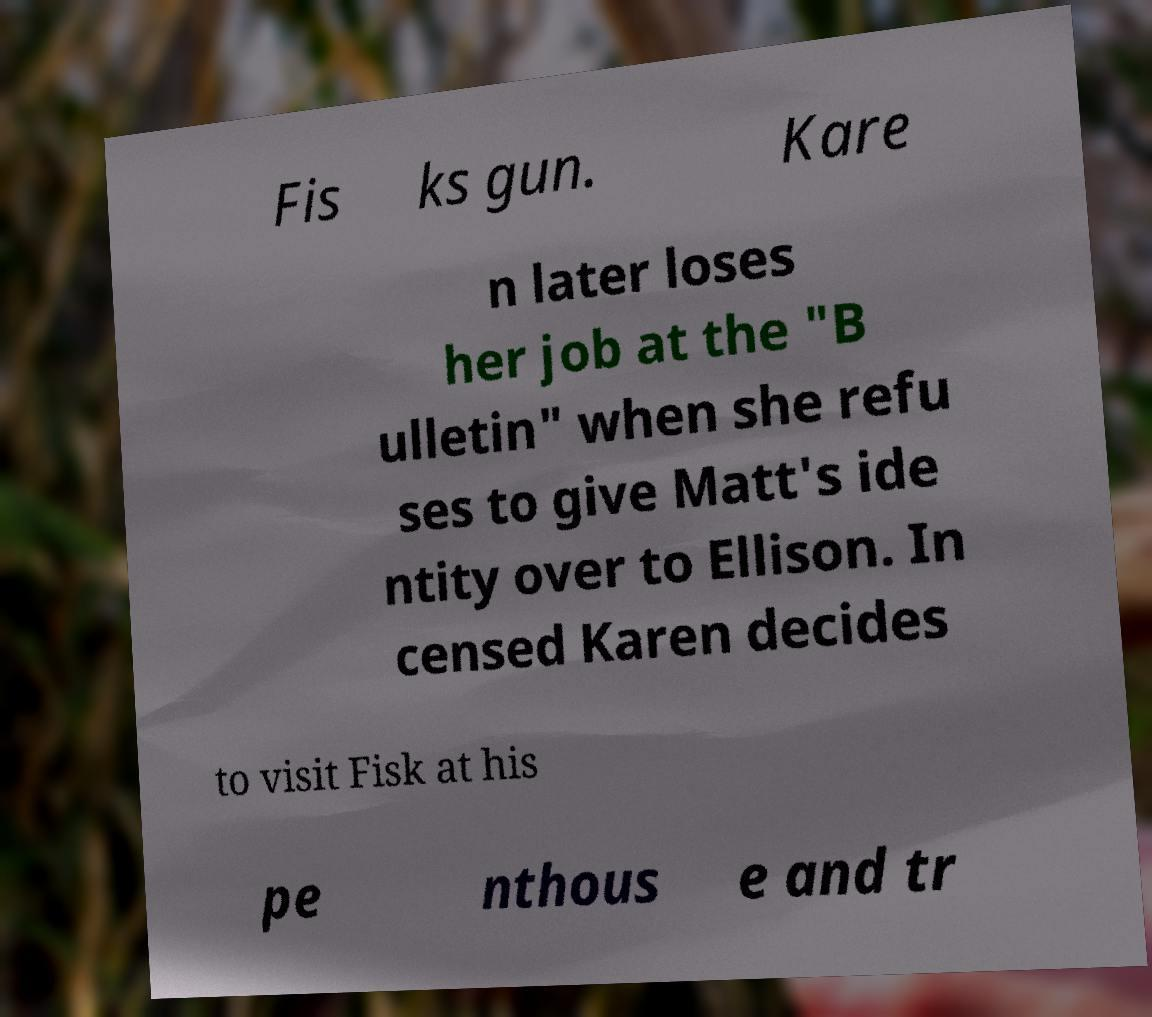For documentation purposes, I need the text within this image transcribed. Could you provide that? Fis ks gun. Kare n later loses her job at the "B ulletin" when she refu ses to give Matt's ide ntity over to Ellison. In censed Karen decides to visit Fisk at his pe nthous e and tr 